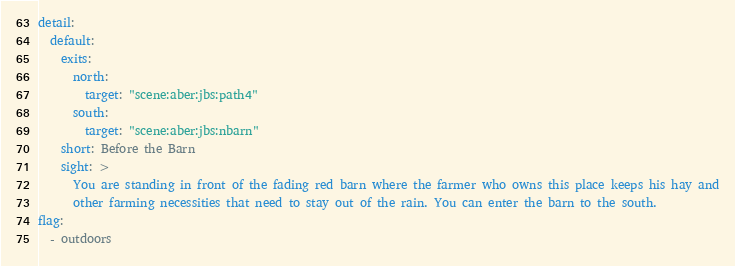<code> <loc_0><loc_0><loc_500><loc_500><_YAML_>detail:
  default:
    exits:
      north:
        target: "scene:aber:jbs:path4"
      south:
        target: "scene:aber:jbs:nbarn"
    short: Before the Barn
    sight: >
      You are standing in front of the fading red barn where the farmer who owns this place keeps his hay and
      other farming necessities that need to stay out of the rain. You can enter the barn to the south.
flag:
  - outdoors
</code> 